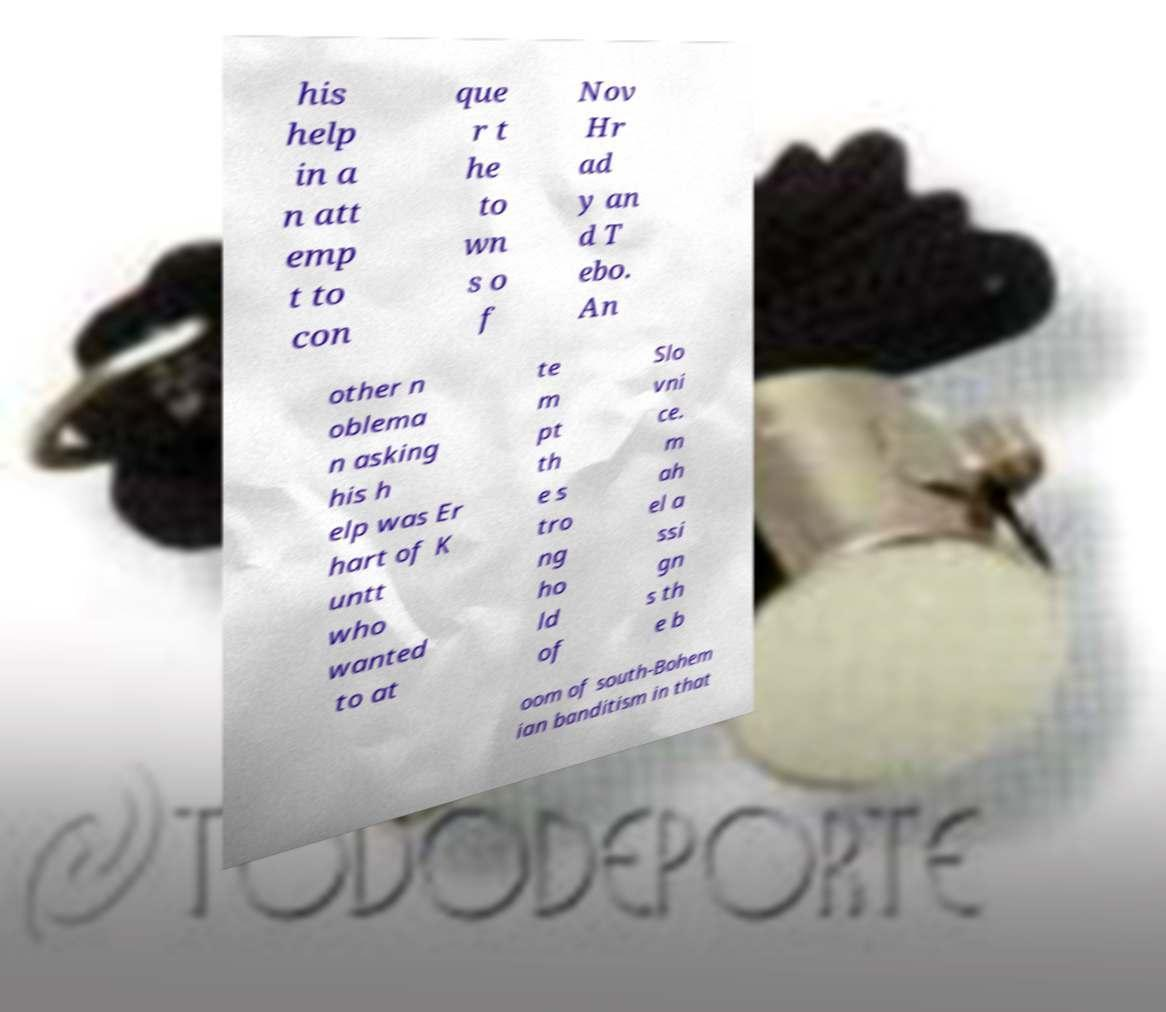There's text embedded in this image that I need extracted. Can you transcribe it verbatim? his help in a n att emp t to con que r t he to wn s o f Nov Hr ad y an d T ebo. An other n oblema n asking his h elp was Er hart of K untt who wanted to at te m pt th e s tro ng ho ld of Slo vni ce. m ah el a ssi gn s th e b oom of south-Bohem ian banditism in that 